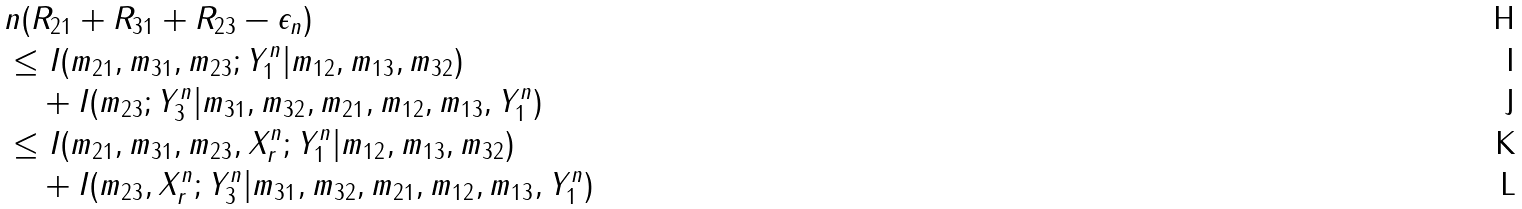Convert formula to latex. <formula><loc_0><loc_0><loc_500><loc_500>& n ( R _ { 2 1 } + R _ { 3 1 } + R _ { 2 3 } - \epsilon _ { n } ) \\ & \leq I ( m _ { 2 1 } , m _ { 3 1 } , m _ { 2 3 } ; Y _ { 1 } ^ { n } | m _ { 1 2 } , m _ { 1 3 } , m _ { 3 2 } ) \\ & \quad + I ( m _ { 2 3 } ; Y _ { 3 } ^ { n } | m _ { 3 1 } , m _ { 3 2 } , m _ { 2 1 } , m _ { 1 2 } , m _ { 1 3 } , Y _ { 1 } ^ { n } ) \\ & \leq I ( m _ { 2 1 } , m _ { 3 1 } , m _ { 2 3 } , X _ { r } ^ { n } ; Y _ { 1 } ^ { n } | m _ { 1 2 } , m _ { 1 3 } , m _ { 3 2 } ) \\ & \quad + I ( m _ { 2 3 } , X _ { r } ^ { n } ; Y _ { 3 } ^ { n } | m _ { 3 1 } , m _ { 3 2 } , m _ { 2 1 } , m _ { 1 2 } , m _ { 1 3 } , Y _ { 1 } ^ { n } )</formula> 